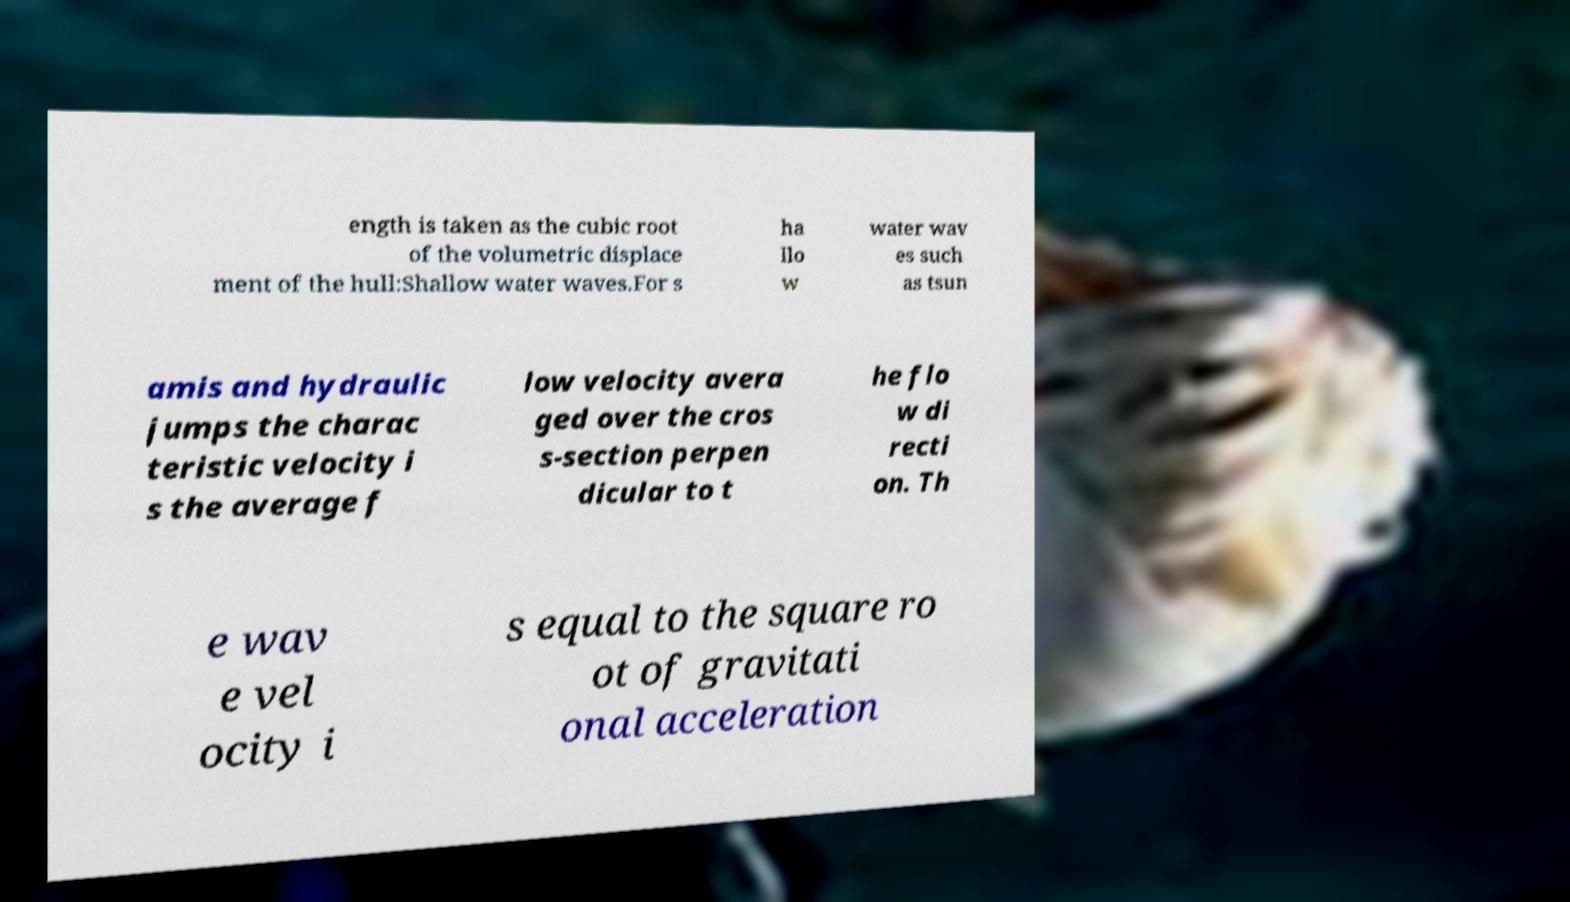I need the written content from this picture converted into text. Can you do that? ength is taken as the cubic root of the volumetric displace ment of the hull:Shallow water waves.For s ha llo w water wav es such as tsun amis and hydraulic jumps the charac teristic velocity i s the average f low velocity avera ged over the cros s-section perpen dicular to t he flo w di recti on. Th e wav e vel ocity i s equal to the square ro ot of gravitati onal acceleration 